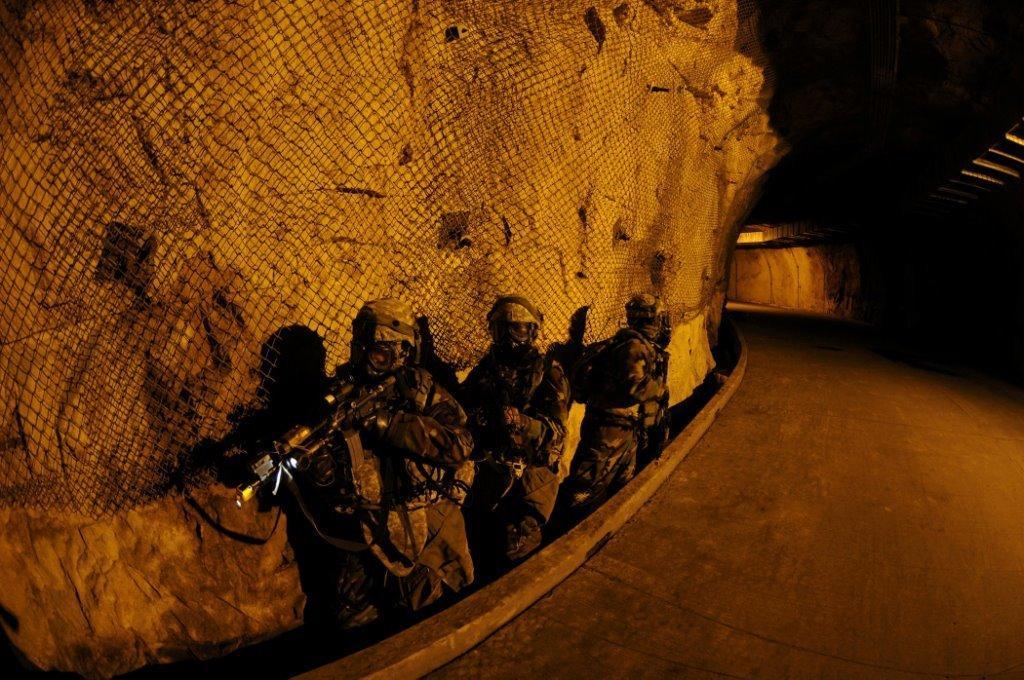Could you give a brief overview of what you see in this image? In the image there are few people wearing similar costumes and holding some weapons, beside them there is a path and in the background there is a net. 